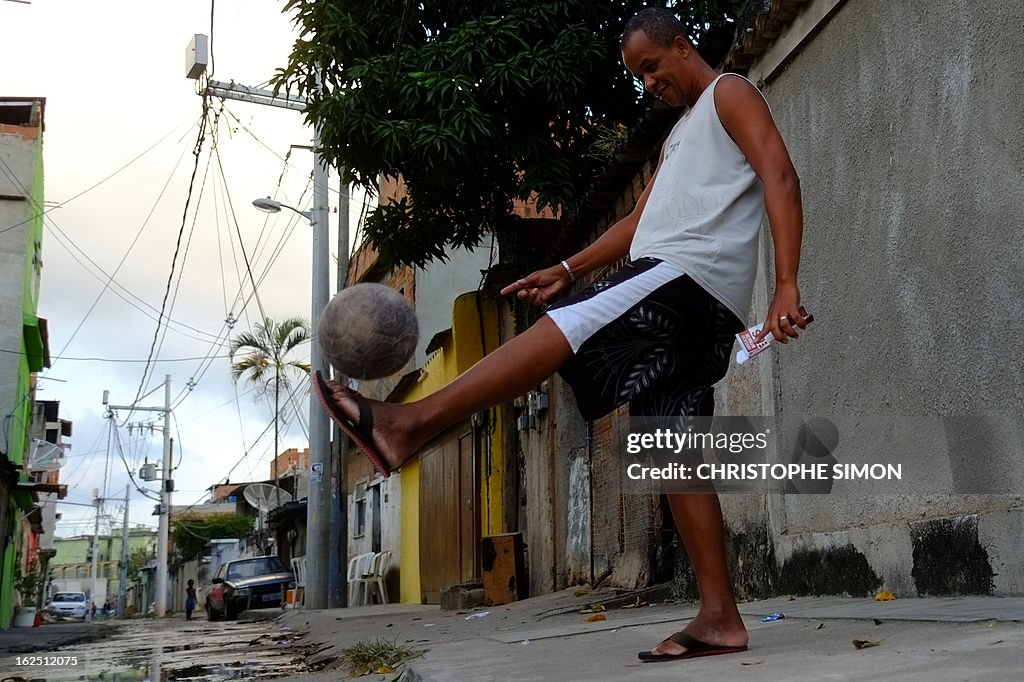Considering the state of the soccer ball and the person's barefoot kick, what could this say about the person's experience or comfort with playing soccer? The worn condition of the soccer ball suggests that it has been used extensively, indicating that soccer is a frequent activity either for the individual or in this locale. The choice to play barefoot, contrasting with more conventional shoed play, highlights a deep level of comfort and possibly a cultural or personal preference for engaging more naturally with the game. It indicates not just habitual playing, but also a skilled adaptability to different playing conditions, underscoring a seasoned, possibly lifelong, engagement with soccer. Moreover, the casual nature of the play, glimpsed through the urban street setting, points to soccer as a spontaneous, joyful activity woven into the daily fabric of life here. 